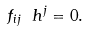Convert formula to latex. <formula><loc_0><loc_0><loc_500><loc_500>f _ { i j } \ h ^ { j } = 0 .</formula> 